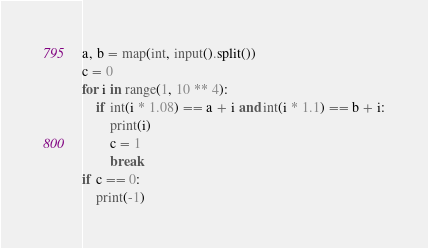<code> <loc_0><loc_0><loc_500><loc_500><_Python_>a, b = map(int, input().split())
c = 0
for i in range(1, 10 ** 4):
    if int(i * 1.08) == a + i and int(i * 1.1) == b + i:
        print(i)
        c = 1
        break
if c == 0:
    print(-1)</code> 